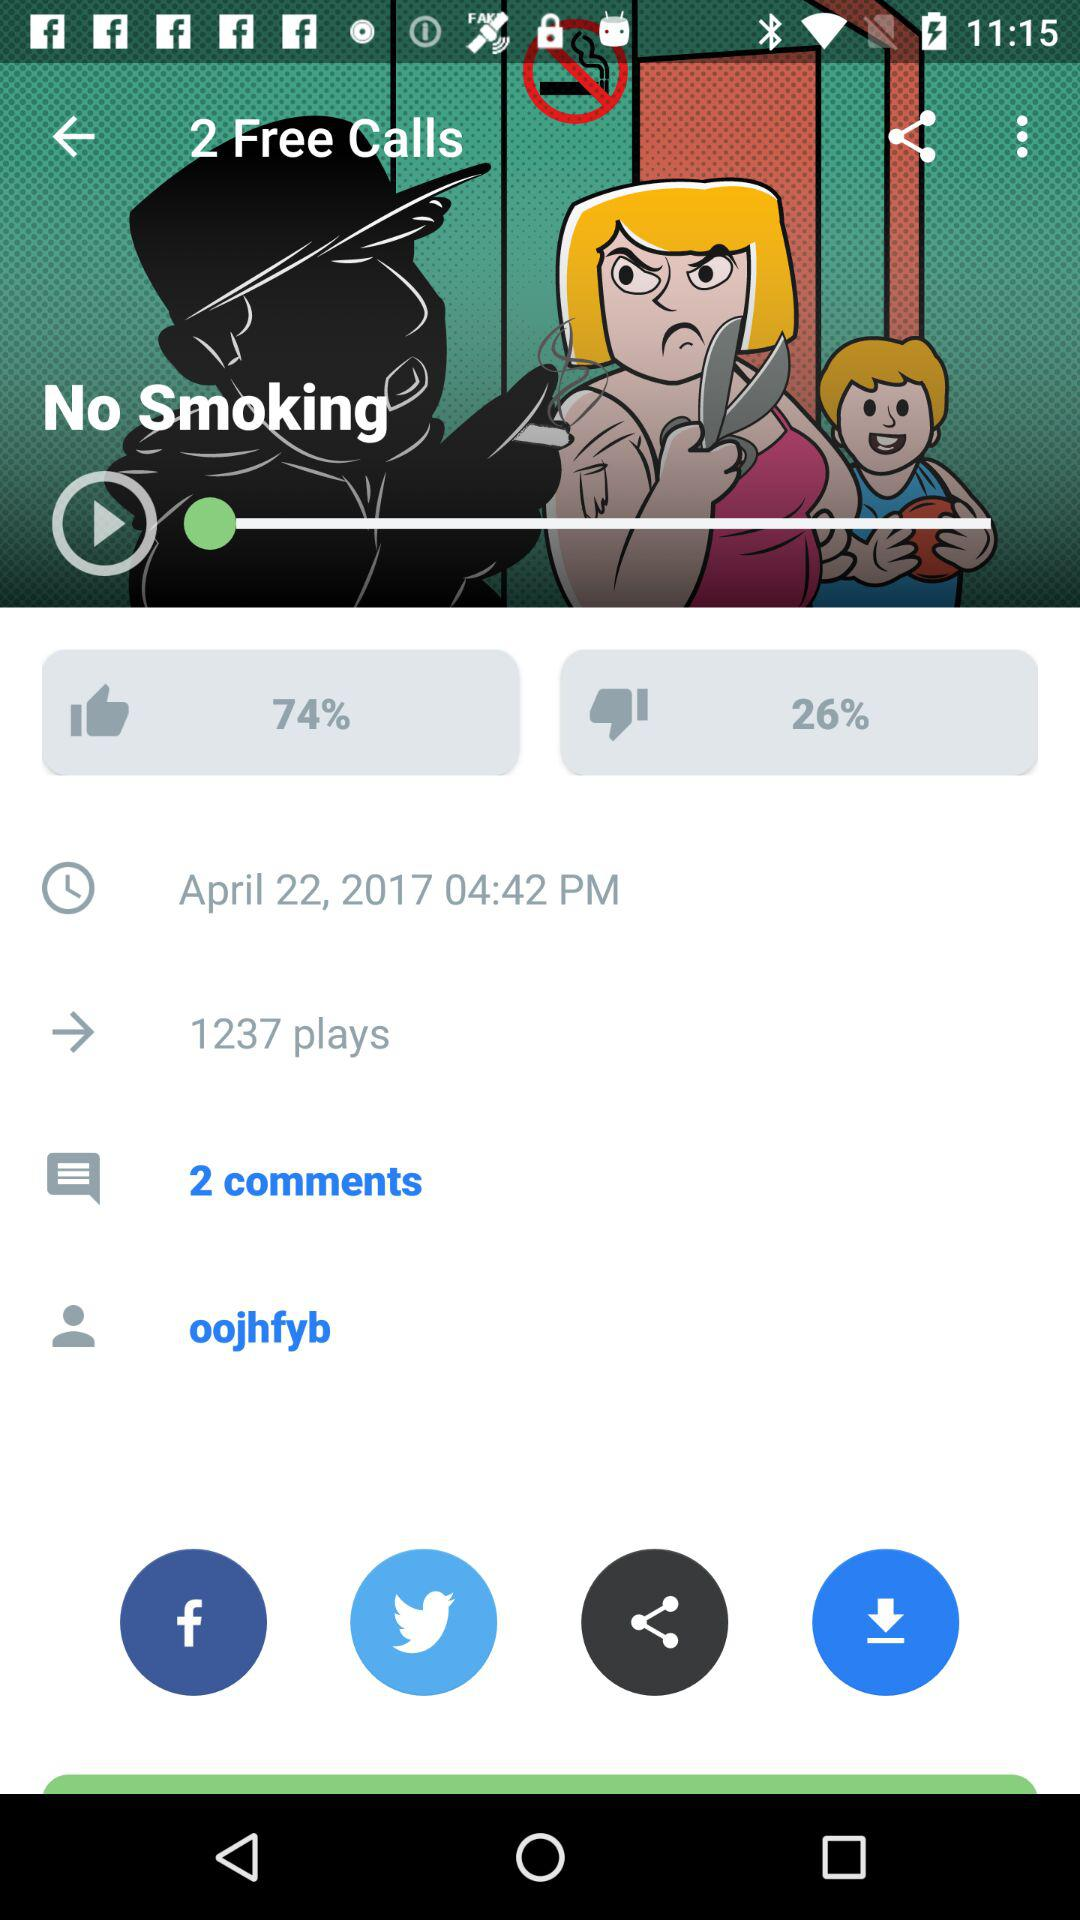What is the count of comments? The count of comments is 2. 